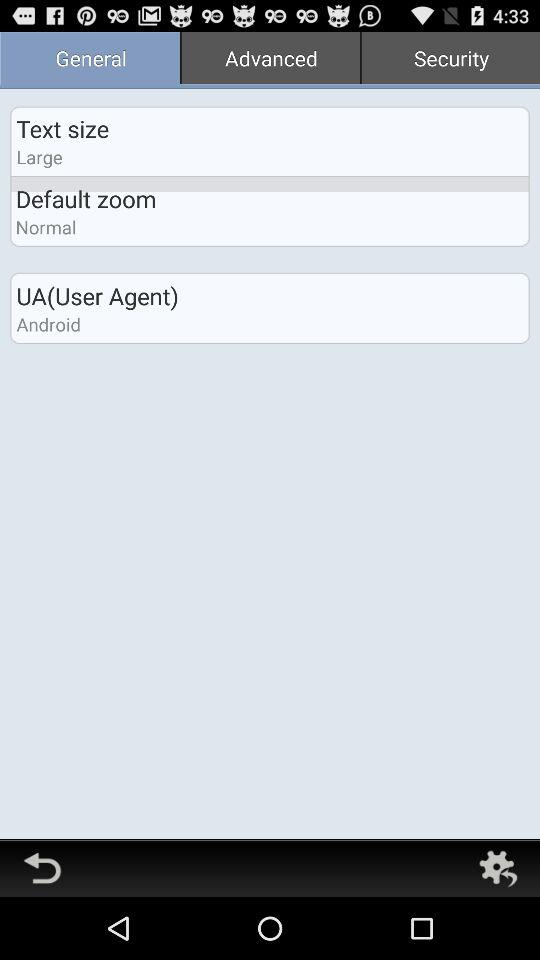What is the selected type of "Default zoom"? The selected type is "Normal". 